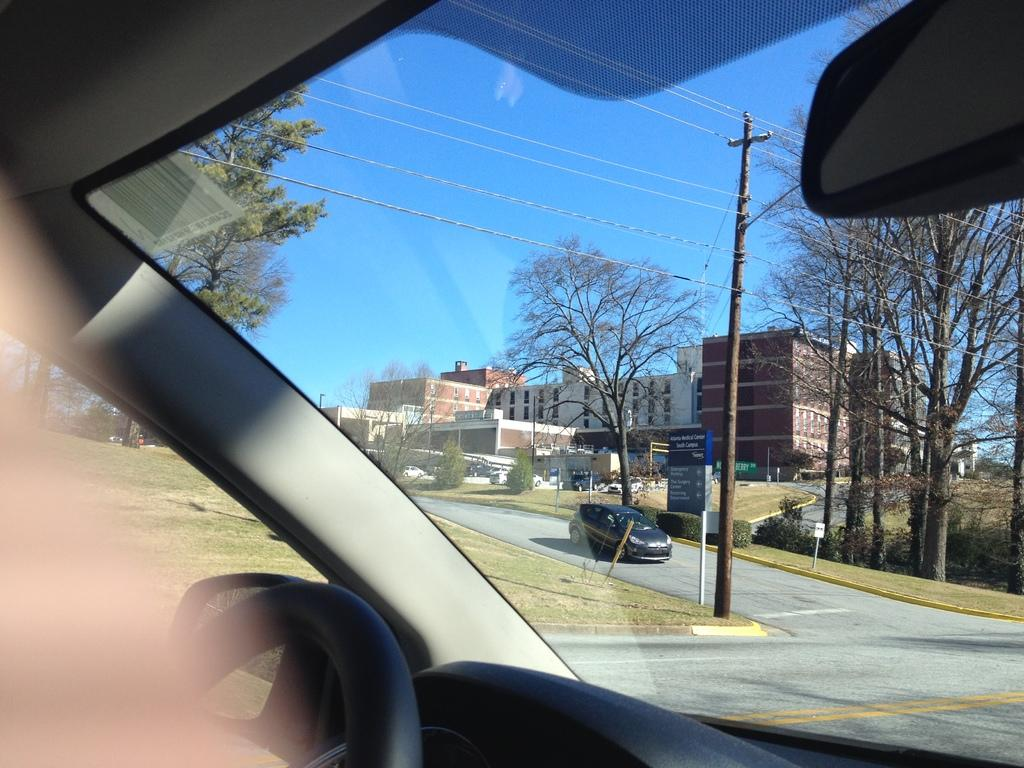What is the perspective of the image? The image is a view from a vehicle. What is present on the road in the image? There is a vehicle on the road in the image. What can be seen in the distance in the image? There are buildings and trees visible in the background of the image. How many birds are flying near the seashore in the image? There is no seashore or birds present in the image. 